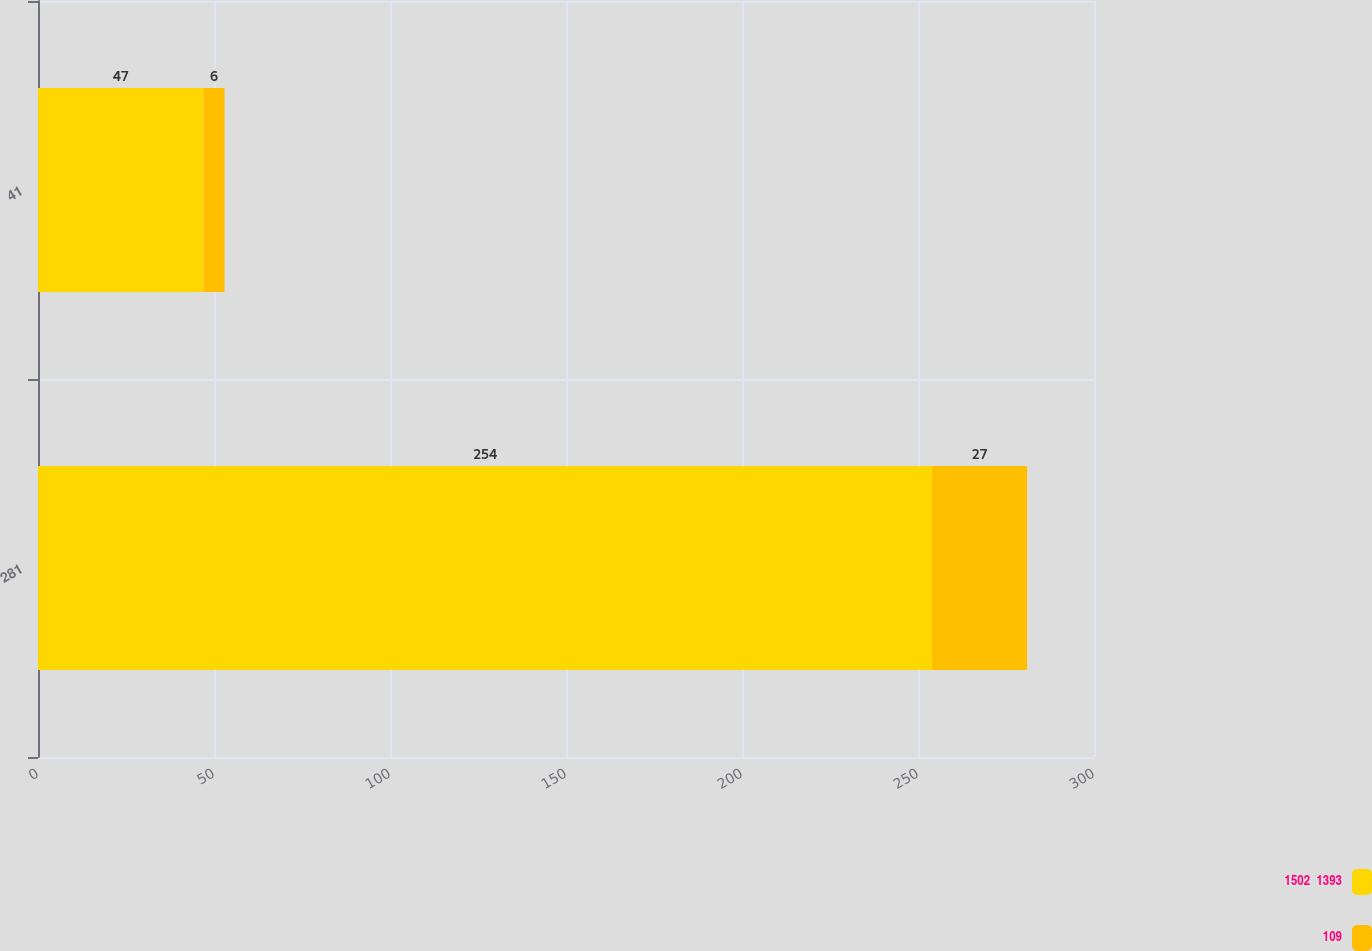Convert chart. <chart><loc_0><loc_0><loc_500><loc_500><stacked_bar_chart><ecel><fcel>281<fcel>41<nl><fcel>1502  1393<fcel>254<fcel>47<nl><fcel>109<fcel>27<fcel>6<nl></chart> 